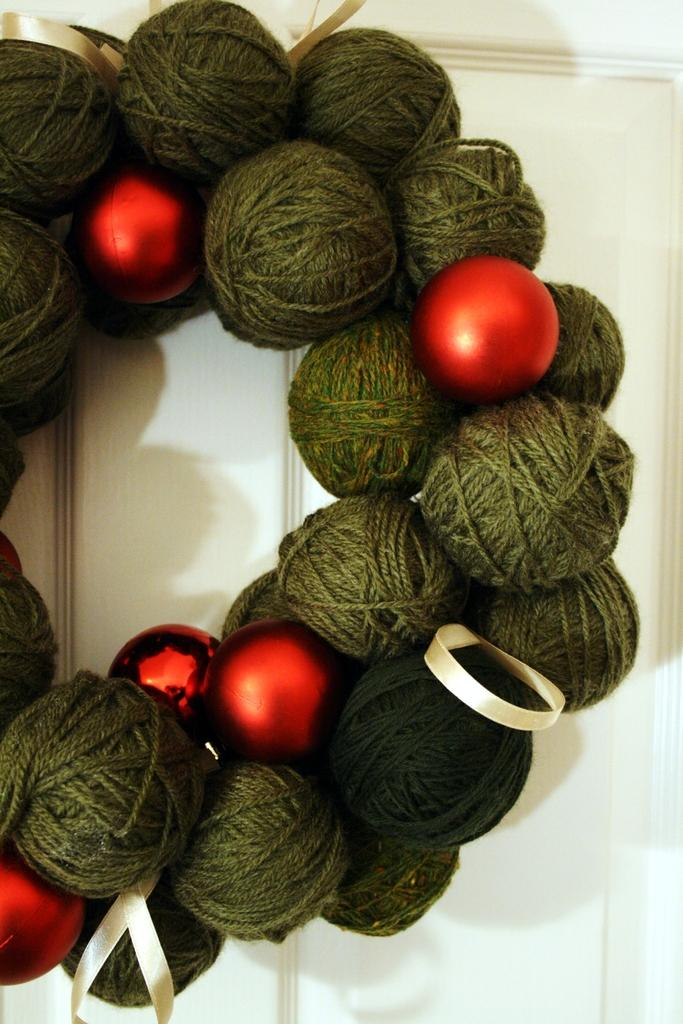What is the main subject of the image? The main subject of the image appears to be a unique Christmas wreath. Can you describe the background of the image? There is a wall in the background of the image. How many toys are hanging from the nerve in the image? There are no toys or nerves present in the image; it features a unique Christmas wreath and a wall in the background. 